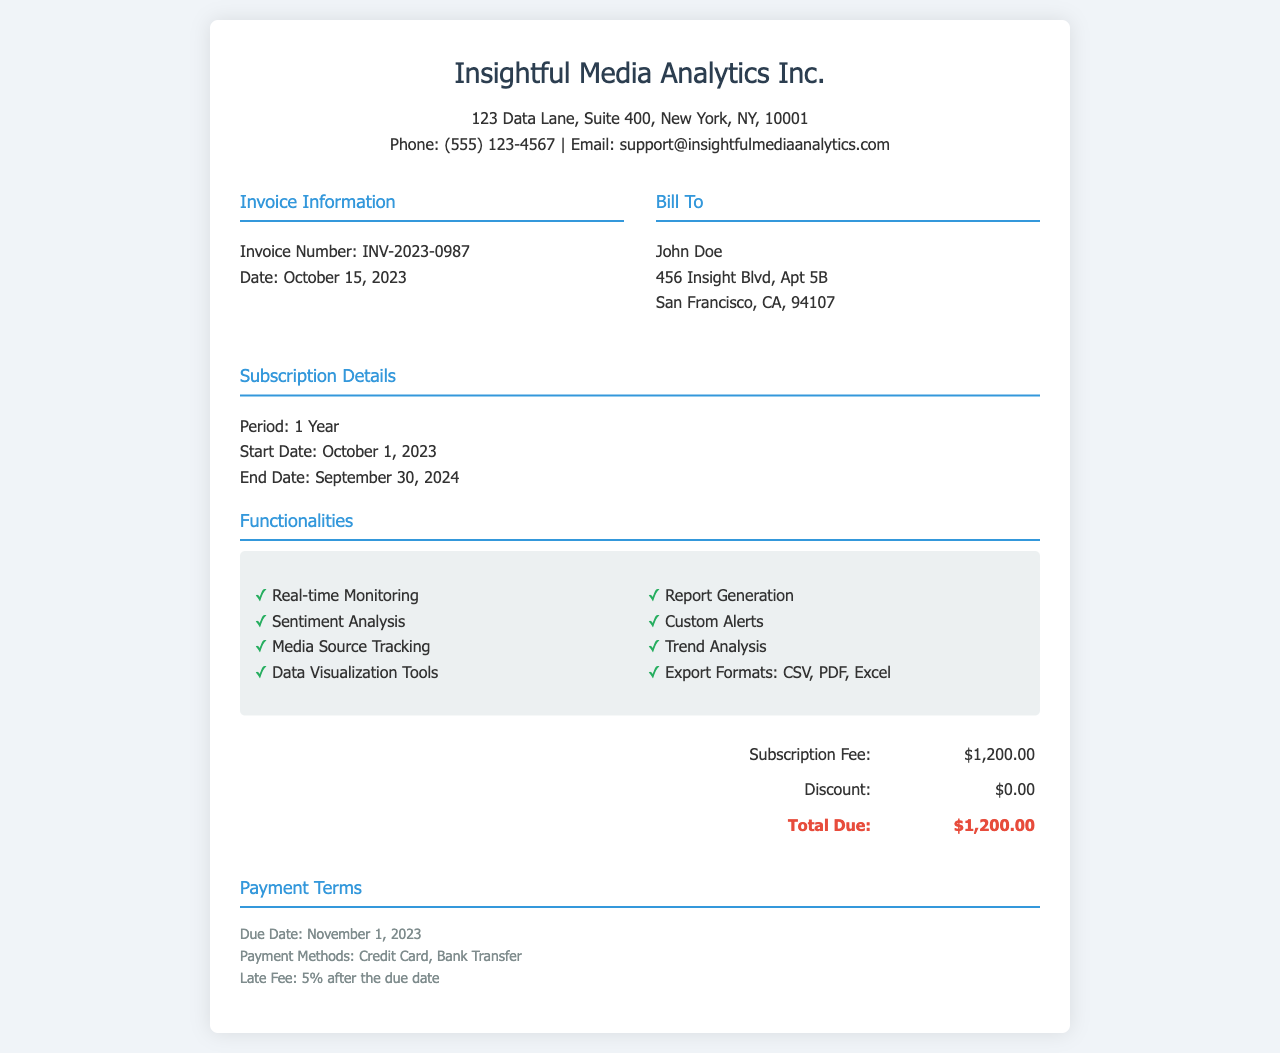What is the invoice number? The invoice number is explicitly stated in the document as INV-2023-0987.
Answer: INV-2023-0987 What is the total due amount? The total due amount is calculated and displayed in the pricing section as $1,200.00.
Answer: $1,200.00 What is the subscription period? The subscription period is mentioned as lasting for 1 year in the subscription details section.
Answer: 1 Year When does the subscription period start? The start date is clearly indicated in the subscription details as October 1, 2023.
Answer: October 1, 2023 What primary functionality is included for media analysis? The functionalities section lists various features including "Real-time Monitoring."
Answer: Real-time Monitoring What is the due date for the payment? The due date for the payment is specified in the payment terms section as November 1, 2023.
Answer: November 1, 2023 What is the company name on the invoice? The company name is prominently displayed at the top of the document as Insightful Media Analytics Inc.
Answer: Insightful Media Analytics Inc What payment methods are available? The available payment methods are listed in the payment terms section as Credit Card and Bank Transfer.
Answer: Credit Card, Bank Transfer 